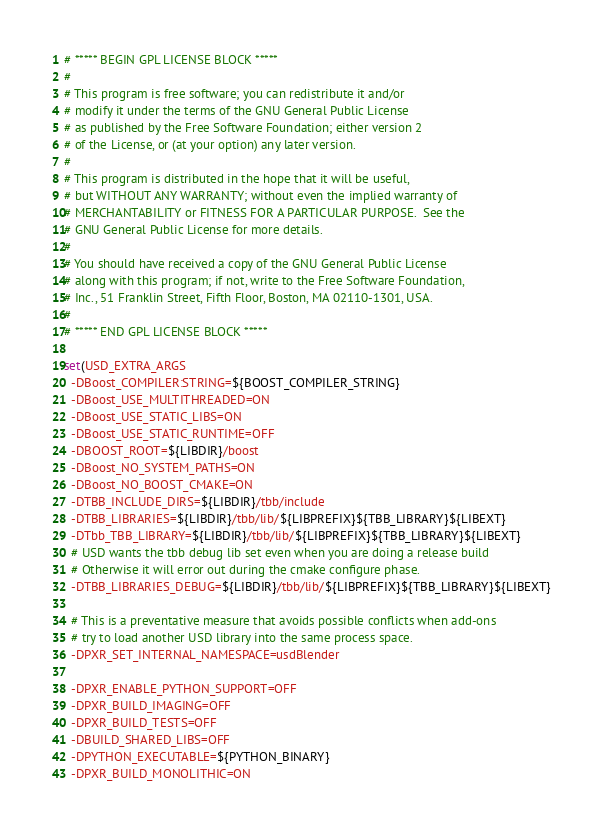Convert code to text. <code><loc_0><loc_0><loc_500><loc_500><_CMake_># ***** BEGIN GPL LICENSE BLOCK *****
#
# This program is free software; you can redistribute it and/or
# modify it under the terms of the GNU General Public License
# as published by the Free Software Foundation; either version 2
# of the License, or (at your option) any later version.
#
# This program is distributed in the hope that it will be useful,
# but WITHOUT ANY WARRANTY; without even the implied warranty of
# MERCHANTABILITY or FITNESS FOR A PARTICULAR PURPOSE.  See the
# GNU General Public License for more details.
#
# You should have received a copy of the GNU General Public License
# along with this program; if not, write to the Free Software Foundation,
# Inc., 51 Franklin Street, Fifth Floor, Boston, MA 02110-1301, USA.
#
# ***** END GPL LICENSE BLOCK *****

set(USD_EXTRA_ARGS
  -DBoost_COMPILER:STRING=${BOOST_COMPILER_STRING}
  -DBoost_USE_MULTITHREADED=ON
  -DBoost_USE_STATIC_LIBS=ON
  -DBoost_USE_STATIC_RUNTIME=OFF
  -DBOOST_ROOT=${LIBDIR}/boost
  -DBoost_NO_SYSTEM_PATHS=ON
  -DBoost_NO_BOOST_CMAKE=ON
  -DTBB_INCLUDE_DIRS=${LIBDIR}/tbb/include
  -DTBB_LIBRARIES=${LIBDIR}/tbb/lib/${LIBPREFIX}${TBB_LIBRARY}${LIBEXT}
  -DTbb_TBB_LIBRARY=${LIBDIR}/tbb/lib/${LIBPREFIX}${TBB_LIBRARY}${LIBEXT}
  # USD wants the tbb debug lib set even when you are doing a release build
  # Otherwise it will error out during the cmake configure phase.
  -DTBB_LIBRARIES_DEBUG=${LIBDIR}/tbb/lib/${LIBPREFIX}${TBB_LIBRARY}${LIBEXT}

  # This is a preventative measure that avoids possible conflicts when add-ons
  # try to load another USD library into the same process space.
  -DPXR_SET_INTERNAL_NAMESPACE=usdBlender

  -DPXR_ENABLE_PYTHON_SUPPORT=OFF
  -DPXR_BUILD_IMAGING=OFF
  -DPXR_BUILD_TESTS=OFF
  -DBUILD_SHARED_LIBS=OFF
  -DPYTHON_EXECUTABLE=${PYTHON_BINARY}
  -DPXR_BUILD_MONOLITHIC=ON
</code> 